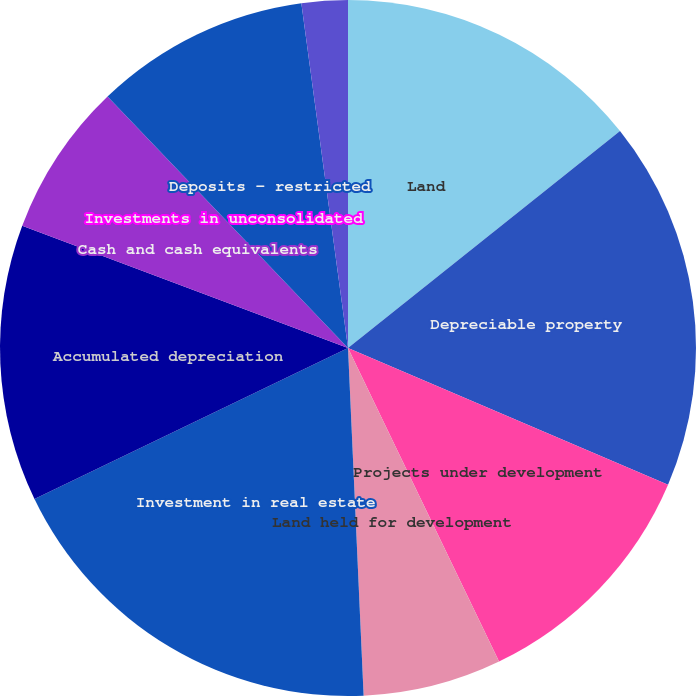Convert chart. <chart><loc_0><loc_0><loc_500><loc_500><pie_chart><fcel>Land<fcel>Depreciable property<fcel>Projects under development<fcel>Land held for development<fcel>Investment in real estate<fcel>Accumulated depreciation<fcel>Cash and cash equivalents<fcel>Investments in unconsolidated<fcel>Deposits - restricted<fcel>Escrow deposits - mortgage<nl><fcel>14.28%<fcel>17.14%<fcel>11.43%<fcel>6.43%<fcel>18.57%<fcel>12.86%<fcel>7.14%<fcel>0.0%<fcel>10.0%<fcel>2.14%<nl></chart> 